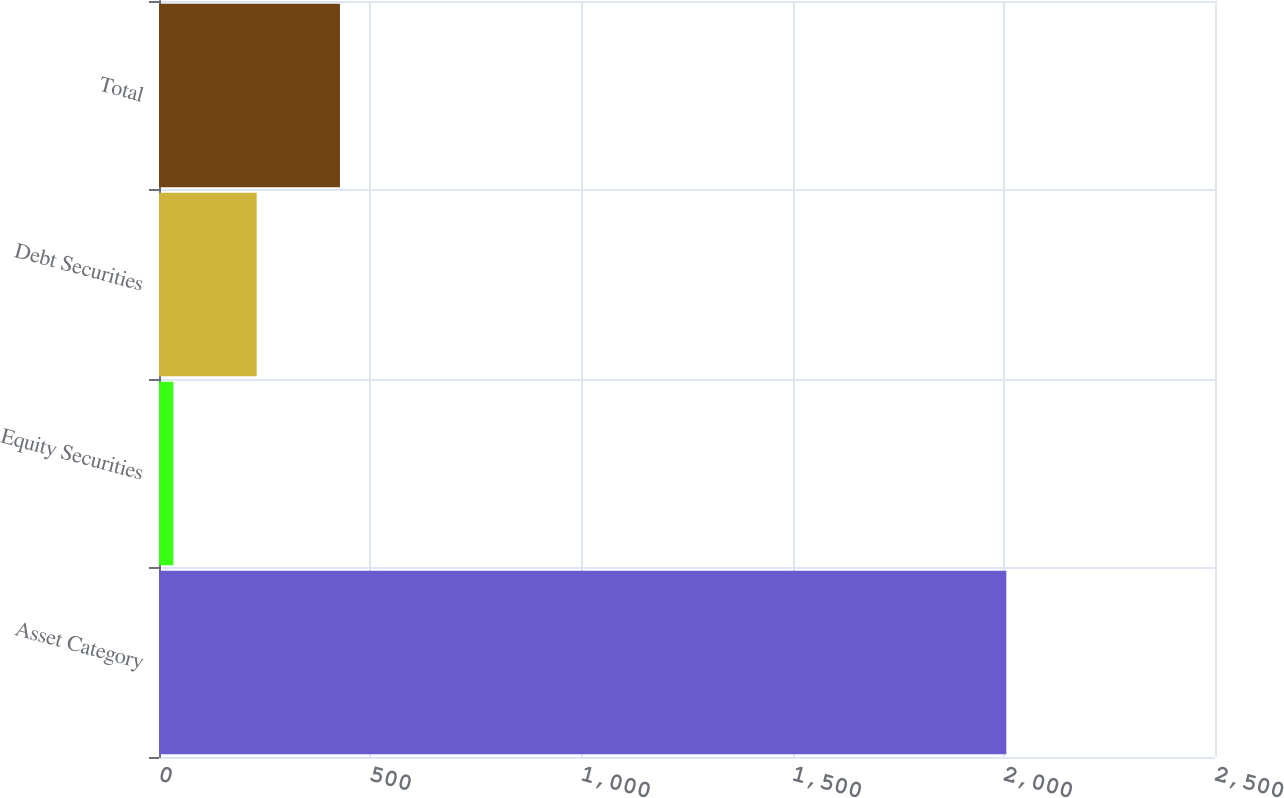Convert chart to OTSL. <chart><loc_0><loc_0><loc_500><loc_500><bar_chart><fcel>Asset Category<fcel>Equity Securities<fcel>Debt Securities<fcel>Total<nl><fcel>2006<fcel>34<fcel>231.2<fcel>428.4<nl></chart> 